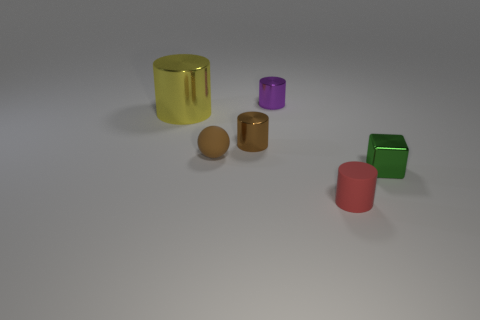Is there anything else that is the same size as the yellow shiny cylinder?
Your answer should be very brief. No. The metallic thing that is on the left side of the tiny purple cylinder and to the right of the big yellow cylinder has what shape?
Your answer should be compact. Cylinder. What is the material of the tiny cylinder that is in front of the shiny object that is in front of the small matte thing that is behind the green thing?
Keep it short and to the point. Rubber. Is the number of small purple shiny cylinders behind the brown rubber ball greater than the number of brown rubber objects in front of the small matte cylinder?
Your answer should be compact. Yes. What number of yellow cylinders are made of the same material as the small red thing?
Your answer should be very brief. 0. Do the tiny shiny thing to the left of the tiny purple metal cylinder and the rubber thing on the right side of the purple cylinder have the same shape?
Offer a terse response. Yes. There is a tiny metallic cylinder that is in front of the yellow cylinder; what is its color?
Keep it short and to the point. Brown. Is there a green thing of the same shape as the tiny red object?
Offer a very short reply. No. What is the material of the sphere?
Provide a succinct answer. Rubber. How big is the thing that is left of the small brown cylinder and behind the brown matte thing?
Provide a short and direct response. Large. 